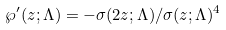Convert formula to latex. <formula><loc_0><loc_0><loc_500><loc_500>\wp ^ { \prime } ( z ; \Lambda ) = - \sigma ( 2 z ; \Lambda ) / \sigma ( z ; \Lambda ) ^ { 4 }</formula> 